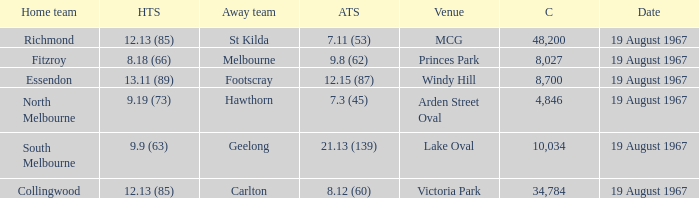What did the home team of essendon score? 13.11 (89). 